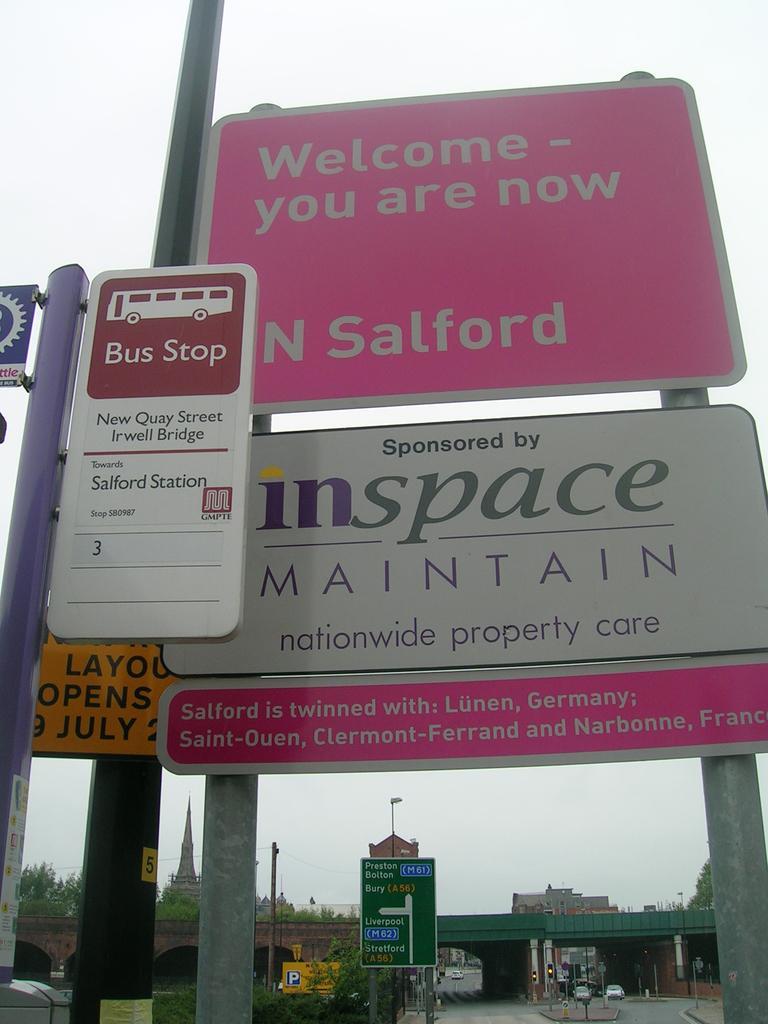Describe this image in one or two sentences. In front of the image there are name boards and sign boards, behind the boards, there are a few other name and sign boards and there is a bridge, beneath the bridge there are a few vehicles passing on the road, on the other side of the bridge there are buildings and trees. 